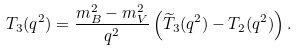Convert formula to latex. <formula><loc_0><loc_0><loc_500><loc_500>T _ { 3 } ( q ^ { 2 } ) = \frac { m _ { B } ^ { 2 } - m _ { V } ^ { 2 } } { q ^ { 2 } } \left ( \widetilde { T } _ { 3 } ( q ^ { 2 } ) - T _ { 2 } ( q ^ { 2 } ) \right ) .</formula> 